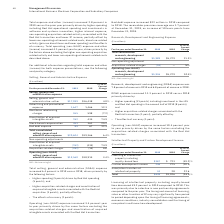According to International Business Machines's financial document, What was the decrease in Licensing of intellectual property? According to the financial document, 49.2 percent. The relevant text states: "l property including royalty-based fees decreased 49.2 percent in 2019 compared to 2018. This was primarily due to a decline in new partnership agreements compare..." Also, What caused the decrease in Licensing of intellectual property? This was primarily due to a decline in new partnership agreements compared to the prior year. The timing and amount of licensing, sales or other transfers of IP may vary significantly from period to period depending upon the timing of licensing agreements, economic conditions, industry consolidation and the timing of new patents and know-how development.. The document states: "s decreased 49.2 percent in 2019 compared to 2018. This was primarily due to a decline in new partnership agreements compared to the prior year. The t..." Also, What was the Custom development income in 2018? According to the financial document, 275 (in millions). The relevant text states: "Custom development income 246 275 (10.5)..." Also, can you calculate: What was the Licensing of intellectual property including royalty-based fees average? To answer this question, I need to perform calculations using the financial data. The calculation is: (367 + 723) / 2, which equals 545 (in millions). This is based on the information: "tual property including royalty-based fees $367 $ 723 (49.2)% tellectual property including royalty-based fees $367 $ 723 (49.2)%..." The key data points involved are: 367, 723. Also, can you calculate: What was the increase / (decrease) in the Custom development income from 2018 to 2019? Based on the calculation: 246 - 275, the result is -29 (in millions). This is based on the information: "Custom development income 246 275 (10.5) Custom development income 246 275 (10.5)..." The key data points involved are: 246, 275. Also, can you calculate: What was the increase / (decrease) in the Sales/other transfers of intellectual property from 2018 to 2019? Based on the calculation: 34 - 28, the result is 6 (in millions). This is based on the information: "Sales/other transfers of intellectual property 34 28 22.6 Sales/other transfers of intellectual property 34 28 22.6..." The key data points involved are: 28, 34. 